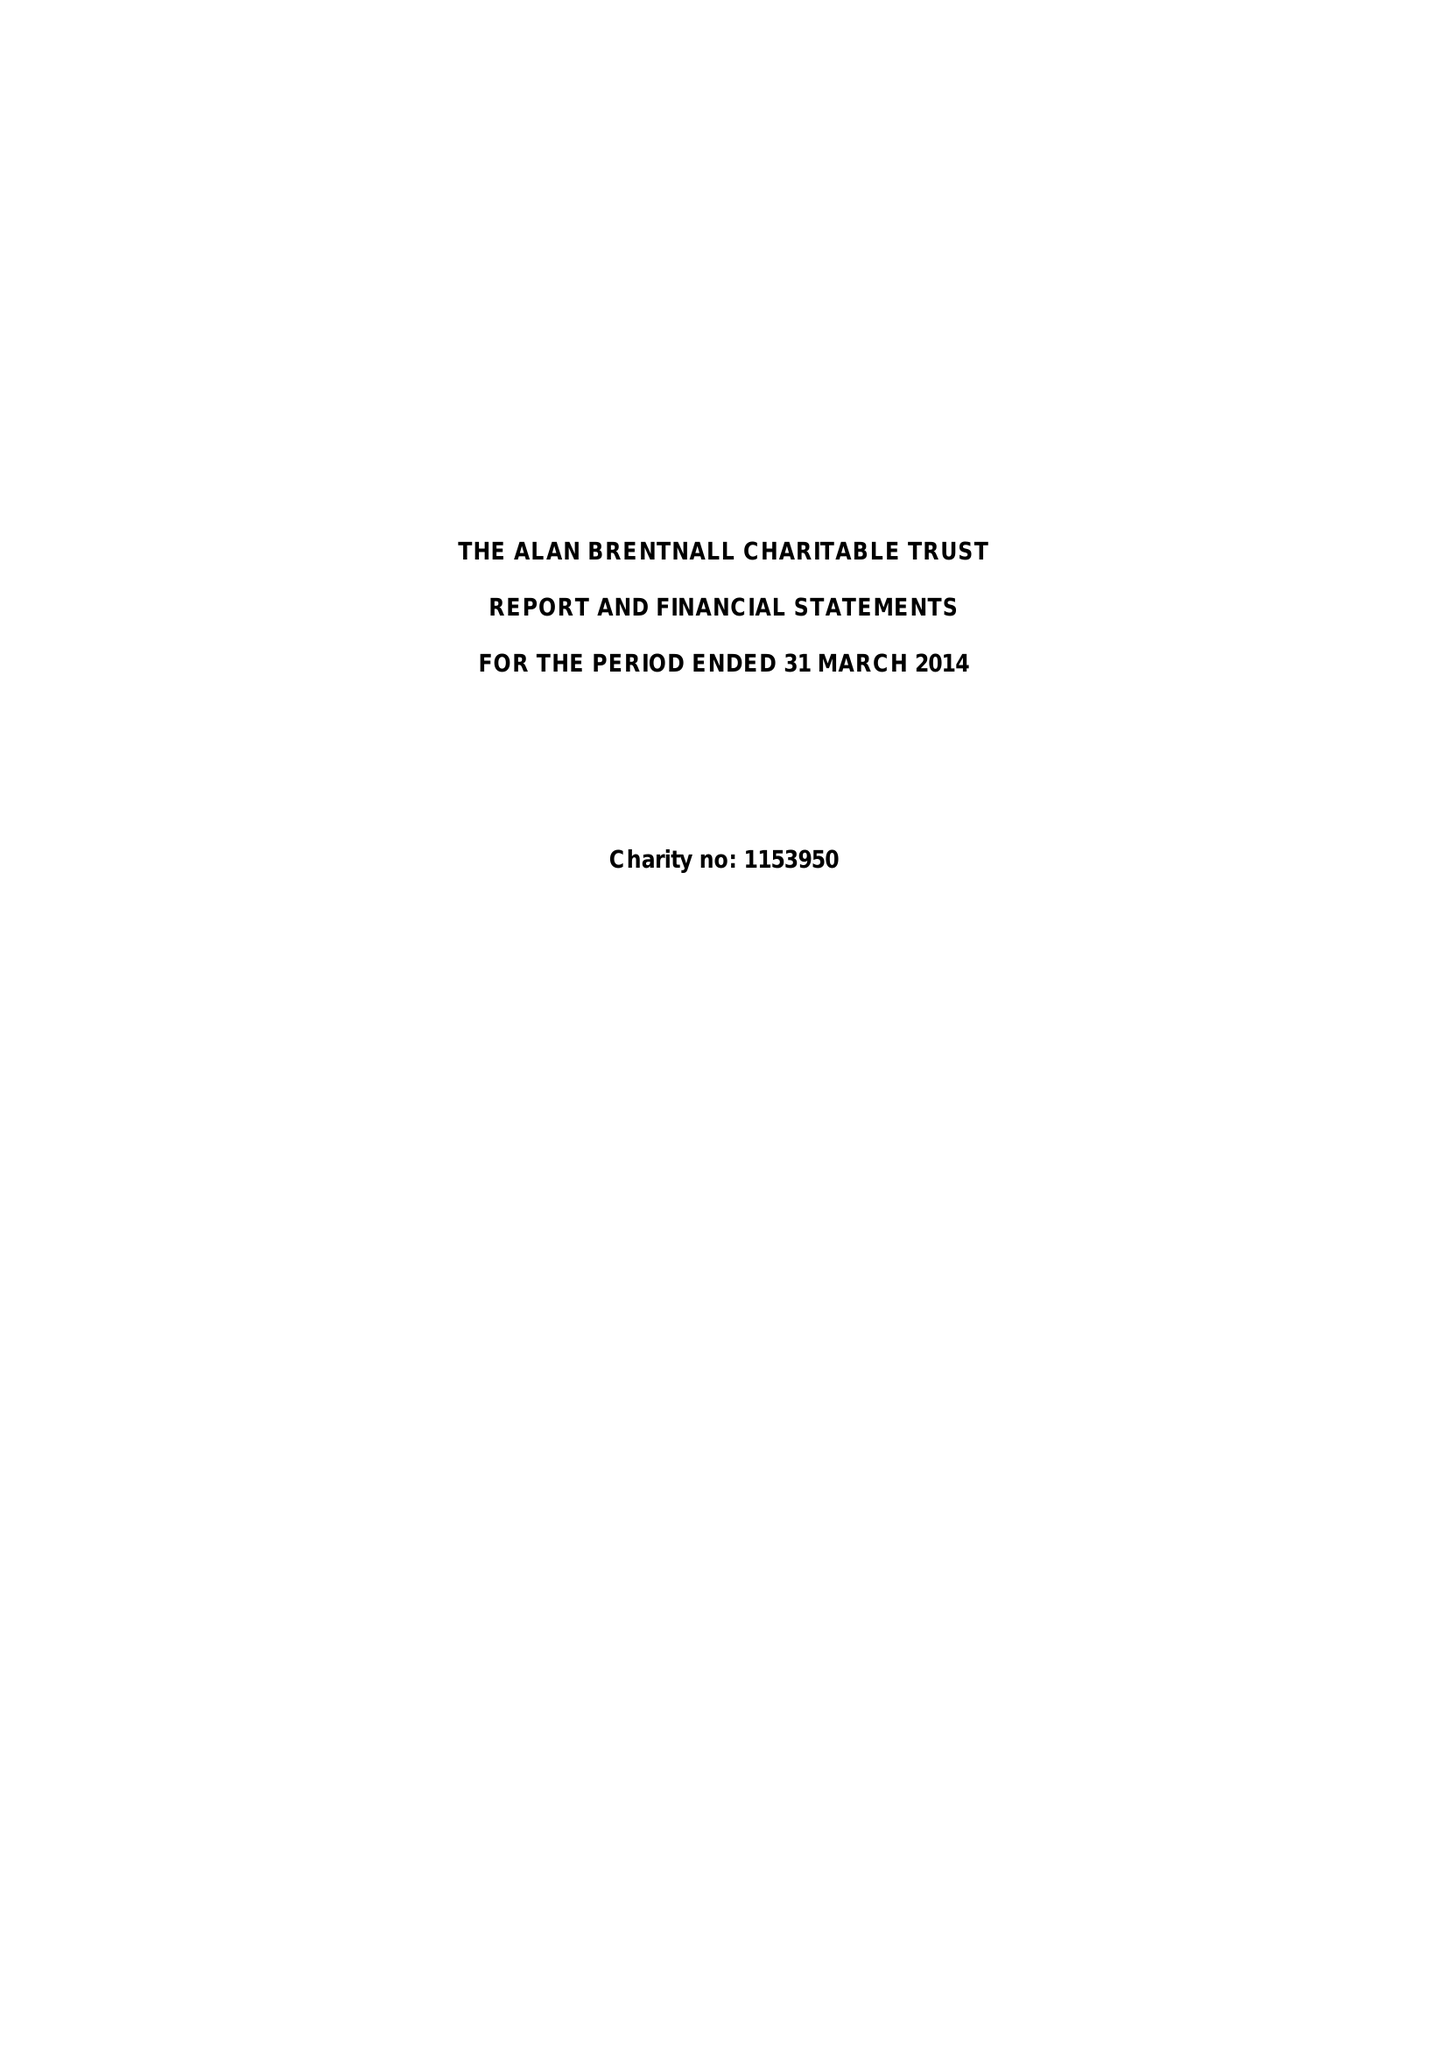What is the value for the address__post_town?
Answer the question using a single word or phrase. FORRES 